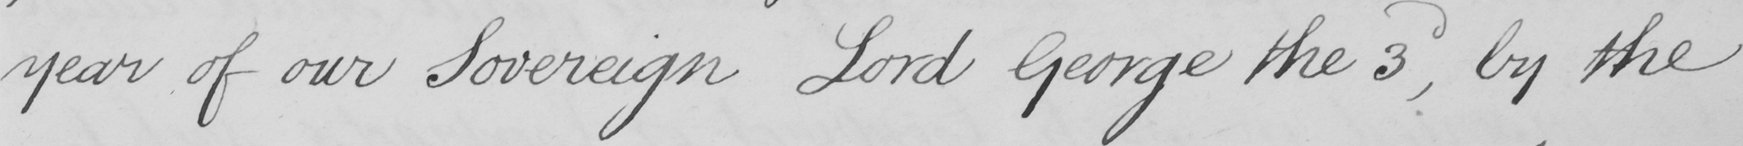Can you tell me what this handwritten text says? year of our Sovereign Lord George the 3d , by the 